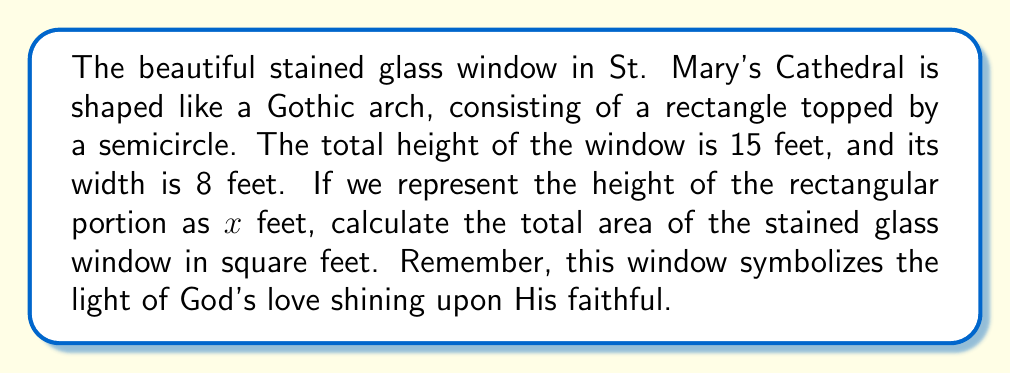What is the answer to this math problem? Let's approach this step-by-step, keeping in mind the geometric properties of the window:

1) The window consists of two parts: a rectangle and a semicircle.

2) Let $x$ be the height of the rectangular portion in feet.

3) The radius of the semicircle is half the width of the window: $r = 8/2 = 4$ feet.

4) The total height is 15 feet, so we can write an equation:
   $x + 4 = 15$ (rectangle height + semicircle radius = total height)

5) Solving for $x$:
   $x = 15 - 4 = 11$ feet

6) Now, we can calculate the areas:

   Rectangle area: $A_r = 8x = 8(11) = 88$ sq ft

   Semicircle area: $A_s = \frac{1}{2}\pi r^2 = \frac{1}{2}\pi(4^2) = 8\pi$ sq ft

7) Total area is the sum of these two:

   $A_{total} = A_r + A_s = 88 + 8\pi$ sq ft

8) If we want to express this as a decimal, we can calculate:
   $A_{total} = 88 + 8\pi \approx 113.14$ sq ft

This area represents the expanse through which God's light shines upon the congregation, illuminating their hearts with divine wisdom.
Answer: The total area of the stained glass window is $88 + 8\pi$ square feet, or approximately 113.14 square feet. 